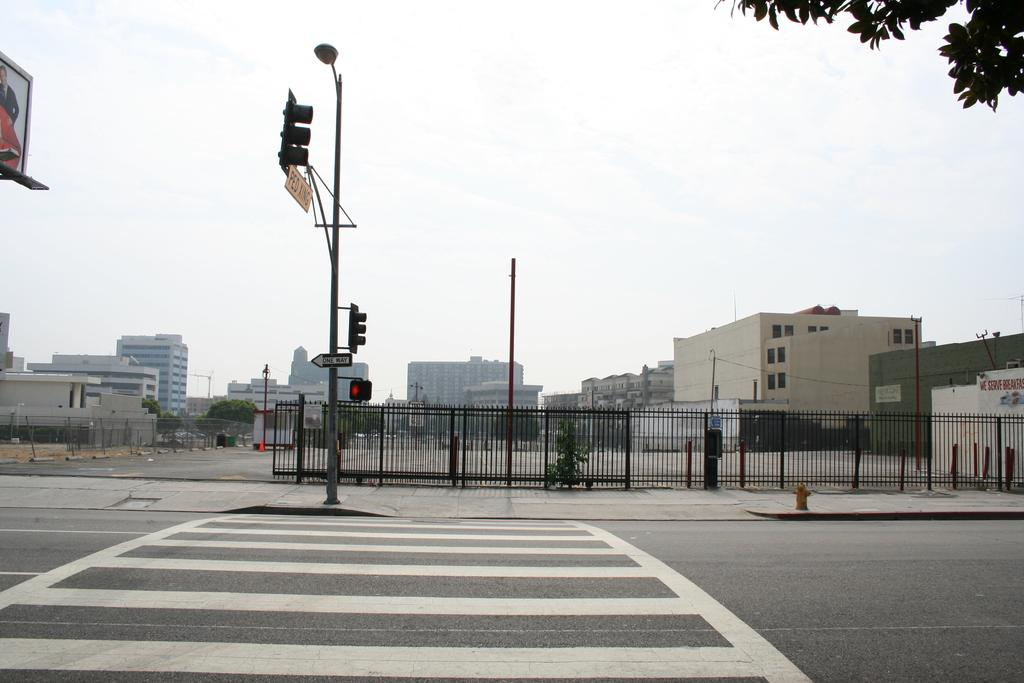What type of signals can be seen in the image? There are traffic signals in the image. What else is present on the poles besides traffic signals? There are posters on the poles in the image. What is separating the different areas in the image? There is a fence in the image. What is the main surface for transportation in the image? There is a road in the image. What type of vegetation is visible in the image? There are trees in the image. What type of structures can be seen in the image? There are buildings in the image. What is visible at the top of the image? The sky is visible in the image, and there are clouds present. What type of quill is being used to write on the posters in the image? There is no quill present in the image; the posters are likely printed or displayed electronically. How are the buildings in the image connected to each other? The buildings in the image are not explicitly connected to each other; they are separate structures. 